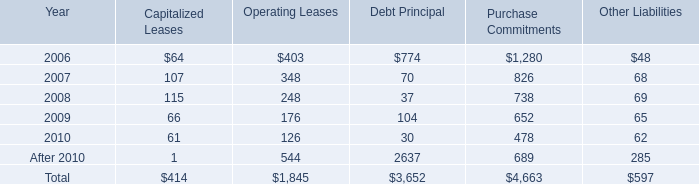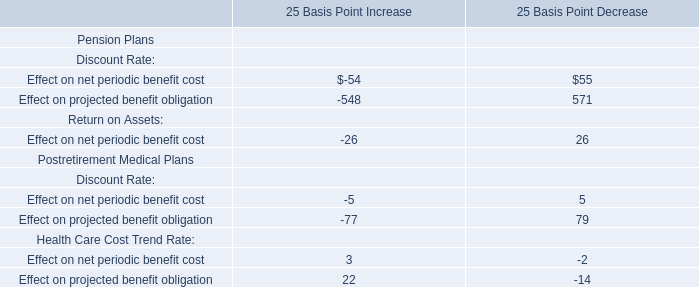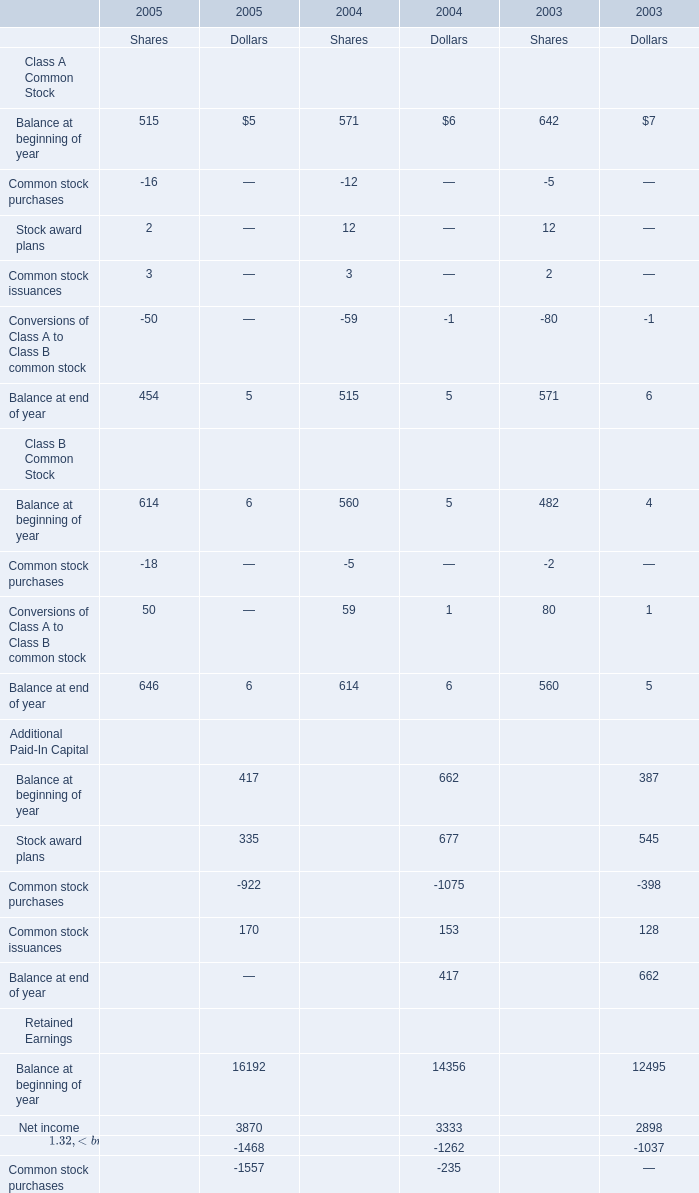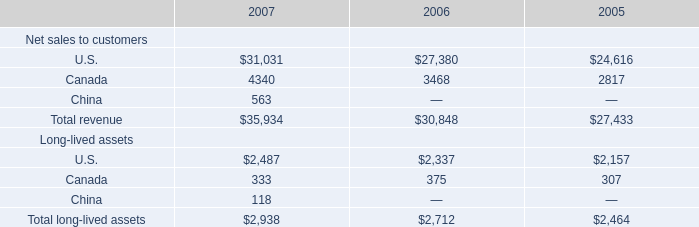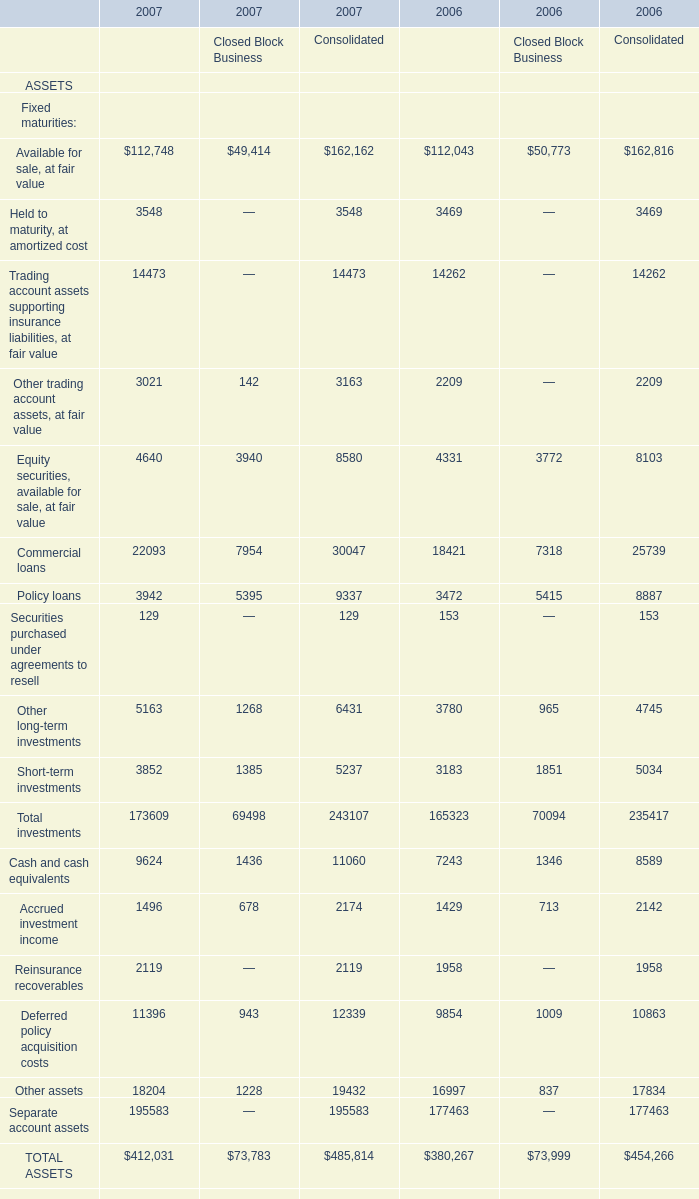Which year is Held to maturity, at amortized cost for Financial Services Businesses greater than 3500? 
Answer: 2007. 